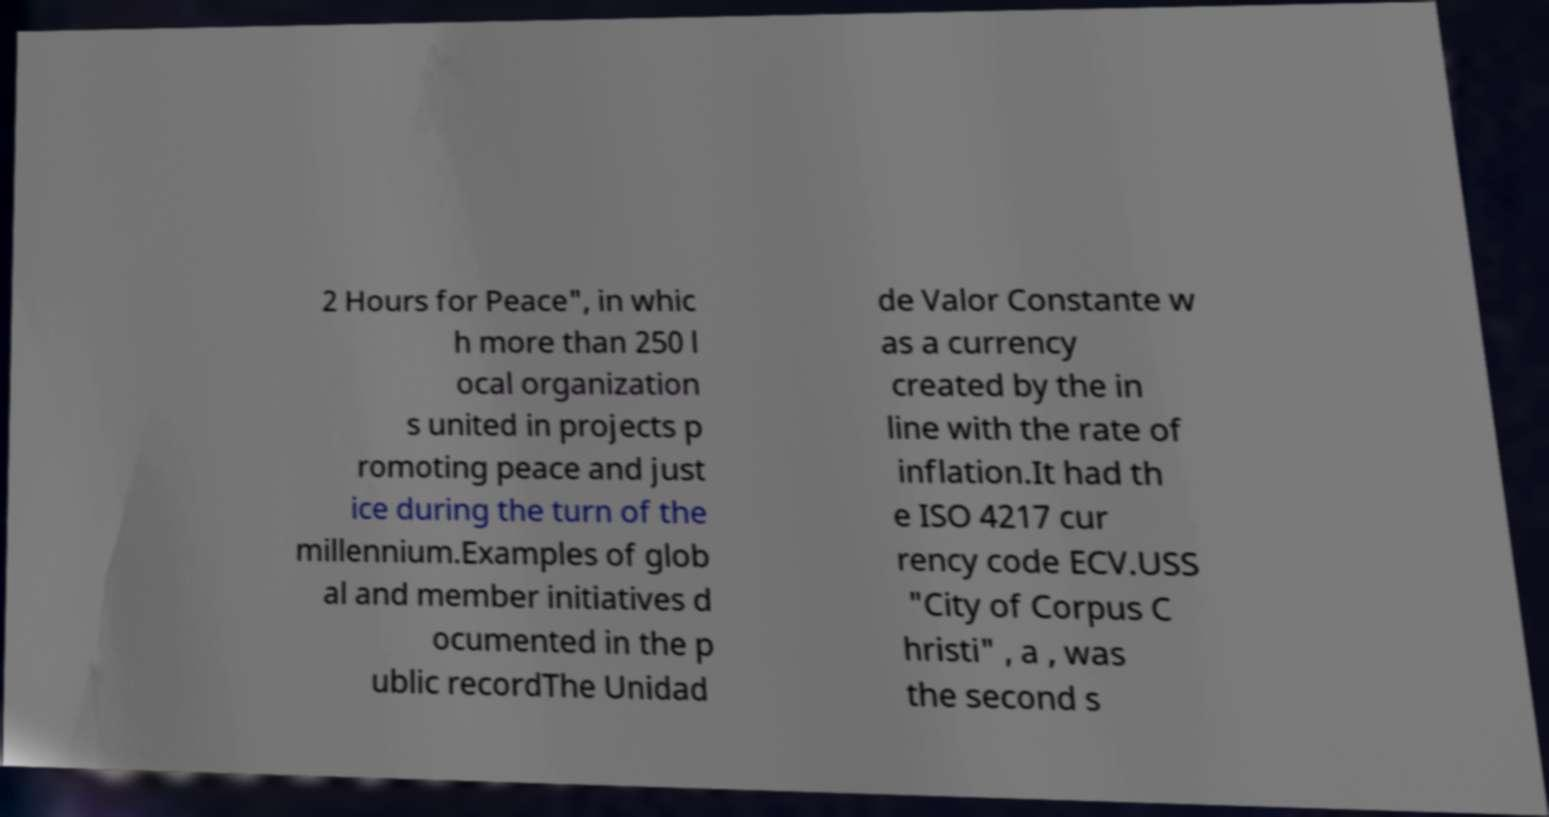Could you assist in decoding the text presented in this image and type it out clearly? 2 Hours for Peace", in whic h more than 250 l ocal organization s united in projects p romoting peace and just ice during the turn of the millennium.Examples of glob al and member initiatives d ocumented in the p ublic recordThe Unidad de Valor Constante w as a currency created by the in line with the rate of inflation.It had th e ISO 4217 cur rency code ECV.USS "City of Corpus C hristi" , a , was the second s 